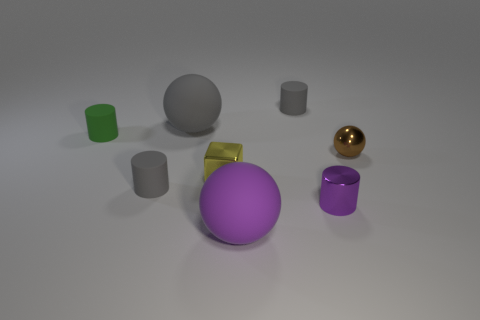Subtract all small green matte cylinders. How many cylinders are left? 3 Subtract all blue spheres. How many gray cylinders are left? 2 Add 1 large brown blocks. How many objects exist? 9 Subtract all green cylinders. How many cylinders are left? 3 Subtract all spheres. How many objects are left? 5 Add 6 purple cylinders. How many purple cylinders are left? 7 Add 5 tiny red metallic cylinders. How many tiny red metallic cylinders exist? 5 Subtract 1 gray balls. How many objects are left? 7 Subtract all brown cylinders. Subtract all red spheres. How many cylinders are left? 4 Subtract all tiny brown objects. Subtract all big matte spheres. How many objects are left? 5 